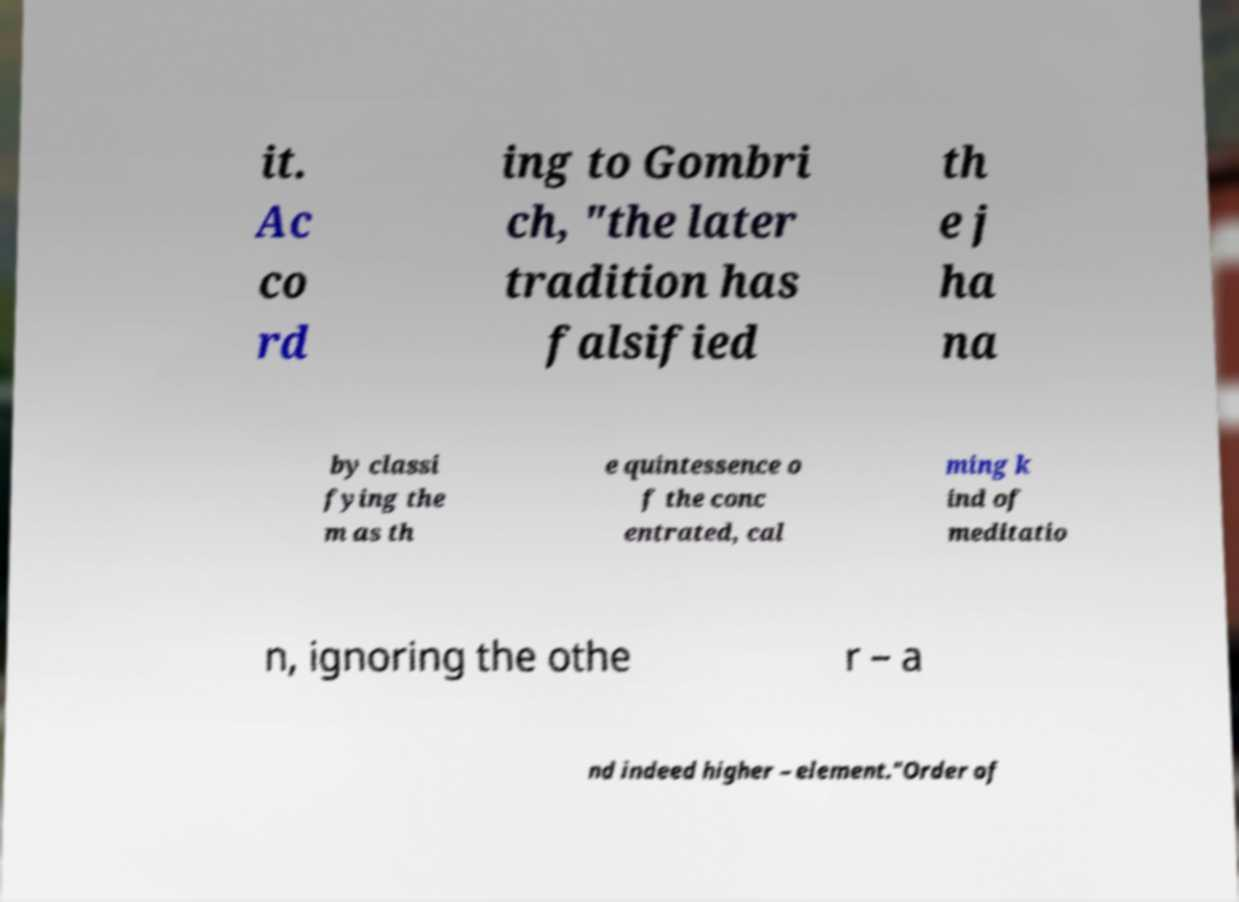For documentation purposes, I need the text within this image transcribed. Could you provide that? it. Ac co rd ing to Gombri ch, "the later tradition has falsified th e j ha na by classi fying the m as th e quintessence o f the conc entrated, cal ming k ind of meditatio n, ignoring the othe r – a nd indeed higher – element."Order of 